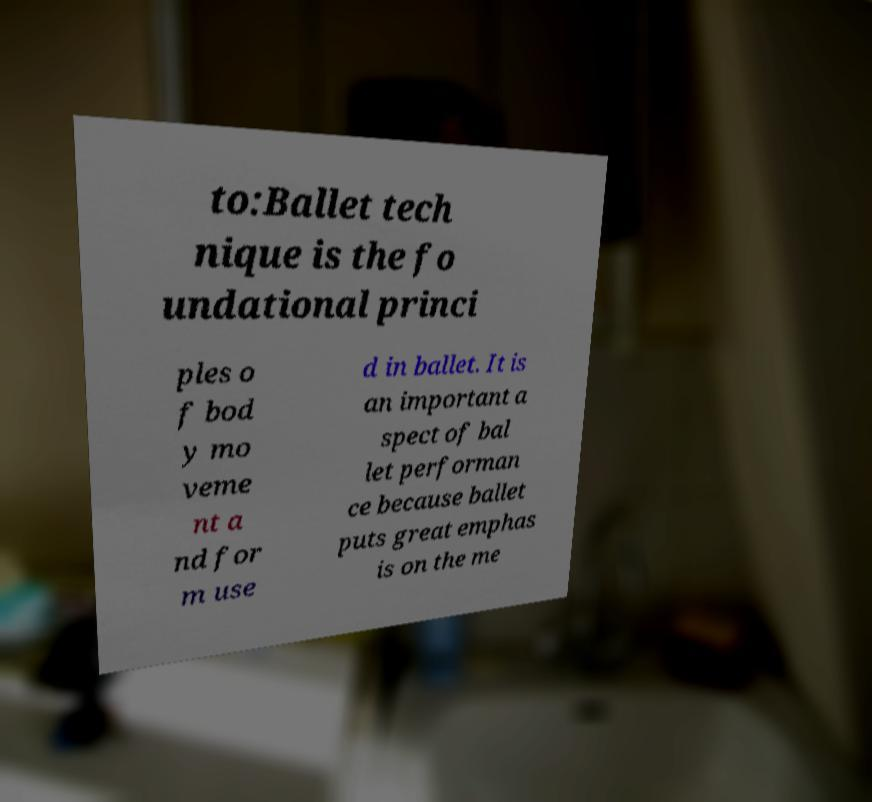There's text embedded in this image that I need extracted. Can you transcribe it verbatim? to:Ballet tech nique is the fo undational princi ples o f bod y mo veme nt a nd for m use d in ballet. It is an important a spect of bal let performan ce because ballet puts great emphas is on the me 